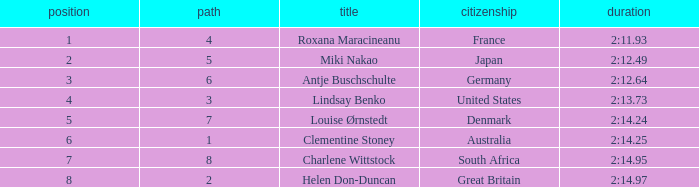What is the number of lane with a rank more than 2 for louise ørnstedt? 1.0. 